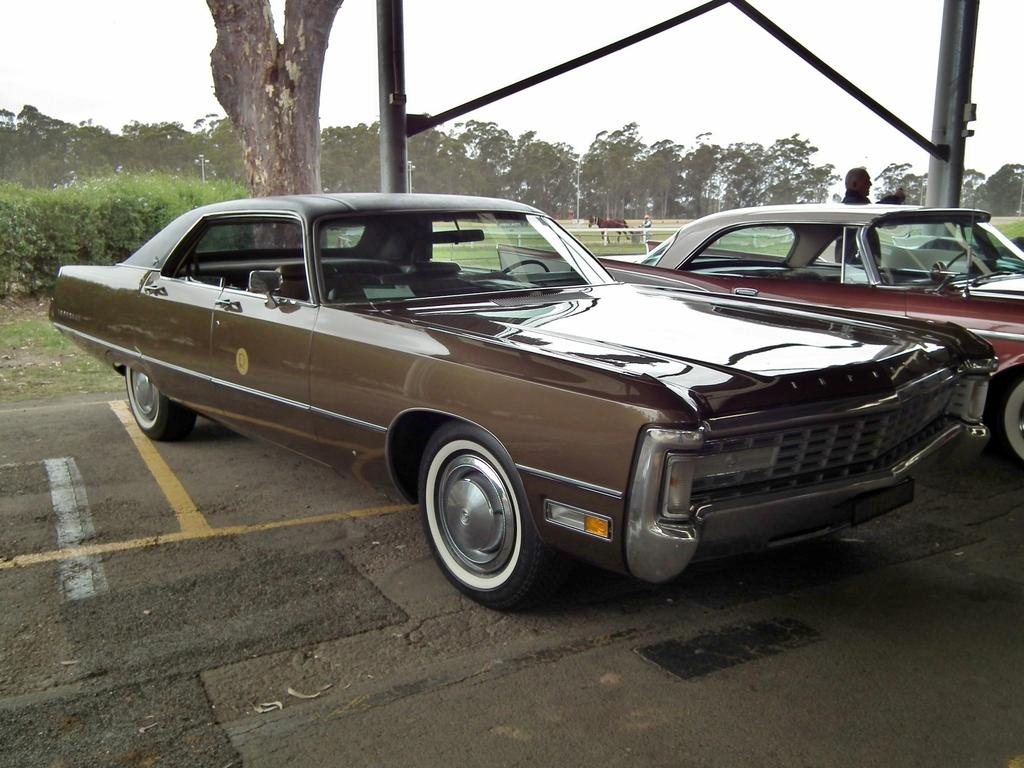How many cars are on the road in the image? There are two cars on the road in the image. What is the person beside one of the cars doing? The person is standing beside one of the cars, but their specific actions are not clear from the image. What other living creature can be seen in the image? There is a horse visible in the image. What type of vegetation is present in the image? Trees are present in the image. What type of linen is draped over the horse in the image? There is no linen draped over the horse in the image; the horse is not wearing any clothing or accessories. 